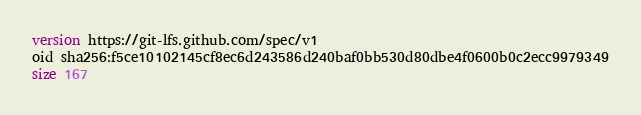Convert code to text. <code><loc_0><loc_0><loc_500><loc_500><_SQL_>version https://git-lfs.github.com/spec/v1
oid sha256:f5ce10102145cf8ec6d243586d240baf0bb530d80dbe4f0600b0c2ecc9979349
size 167
</code> 